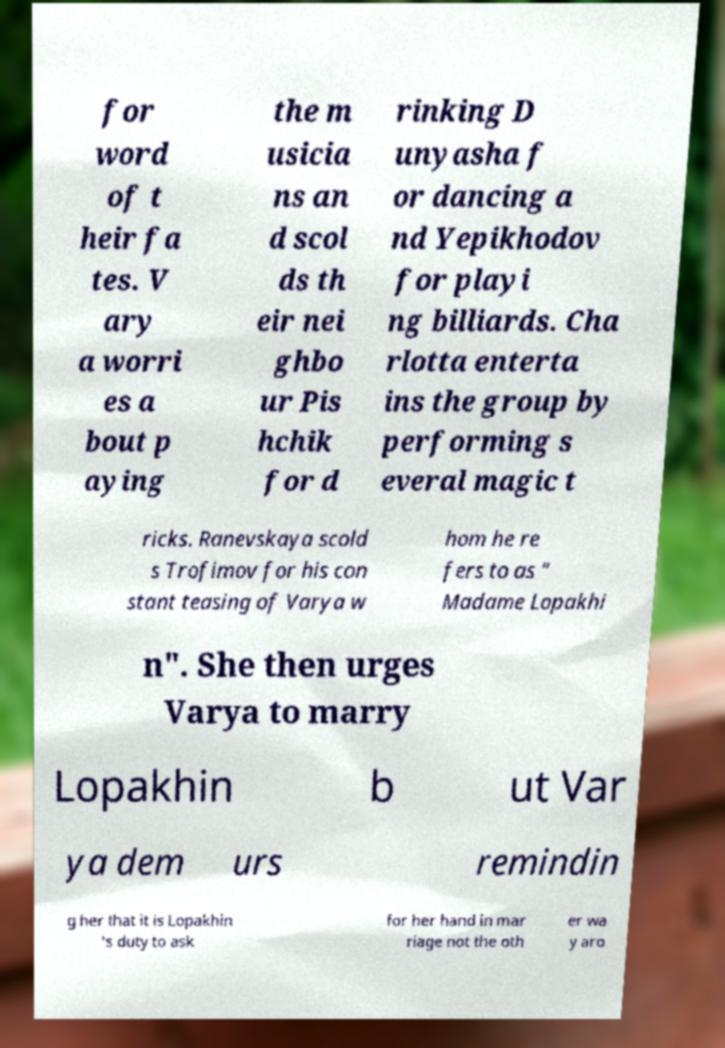Can you read and provide the text displayed in the image?This photo seems to have some interesting text. Can you extract and type it out for me? for word of t heir fa tes. V ary a worri es a bout p aying the m usicia ns an d scol ds th eir nei ghbo ur Pis hchik for d rinking D unyasha f or dancing a nd Yepikhodov for playi ng billiards. Cha rlotta enterta ins the group by performing s everal magic t ricks. Ranevskaya scold s Trofimov for his con stant teasing of Varya w hom he re fers to as " Madame Lopakhi n". She then urges Varya to marry Lopakhin b ut Var ya dem urs remindin g her that it is Lopakhin 's duty to ask for her hand in mar riage not the oth er wa y aro 